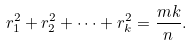<formula> <loc_0><loc_0><loc_500><loc_500>r _ { 1 } ^ { 2 } + r _ { 2 } ^ { 2 } + \dots + r _ { k } ^ { 2 } = \frac { m k } { n } .</formula> 